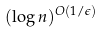<formula> <loc_0><loc_0><loc_500><loc_500>( \log n ) ^ { O ( 1 / \epsilon ) }</formula> 